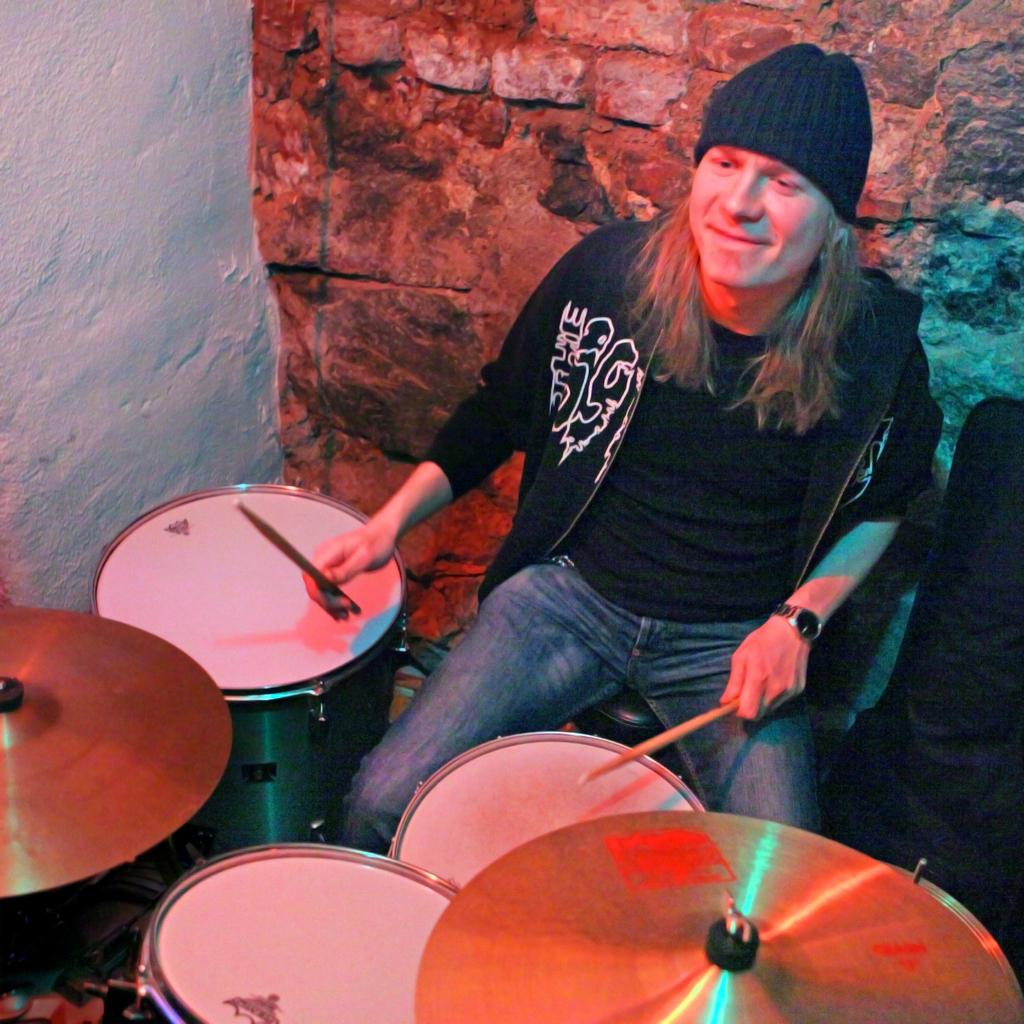What is the person in the image doing? The person is playing music drums. What can be seen behind the person in the image? There is a wall visible in the image. What type of riddle is the person solving while playing the drums in the image? There is no riddle present in the image; the person is simply playing music drums. Can you see a sponge being used by the person in the image? There is no sponge visible in the image. 